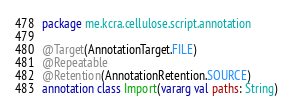Convert code to text. <code><loc_0><loc_0><loc_500><loc_500><_Kotlin_>package me.kcra.cellulose.script.annotation

@Target(AnnotationTarget.FILE)
@Repeatable
@Retention(AnnotationRetention.SOURCE)
annotation class Import(vararg val paths: String)
</code> 